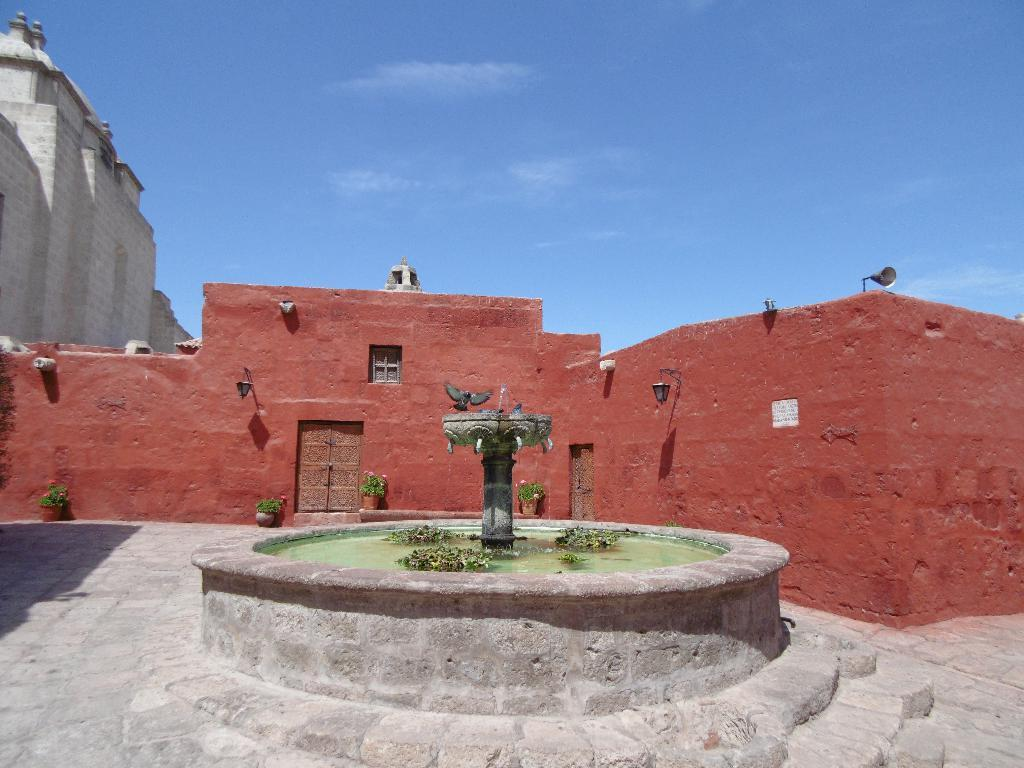What is the main feature in the image? There is a fountain in the image. Are there any living creatures present in the image? Yes, there is a bird in the image. What can be seen in the background of the image? There are buildings in the background of the image. What colors are the buildings? The buildings are in brown and gray colors. What colors are visible in the sky? The sky is in blue and white colors. What type of pie is being served at the train station in the image? There is no train station or pie present in the image; it features a fountain, a bird, buildings, and a sky. How many copies of the bird can be seen in the image? There is only one bird visible in the image. 